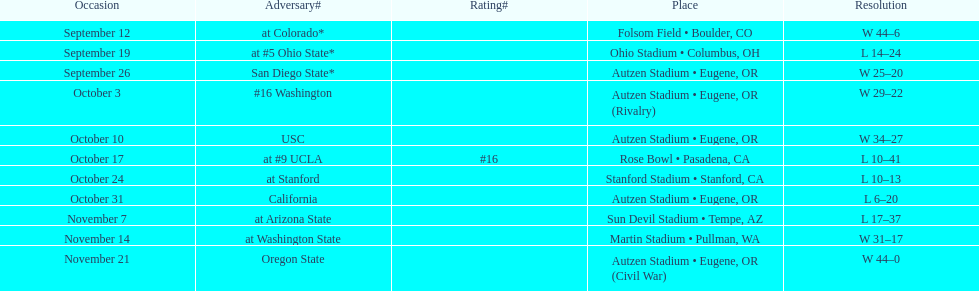How many games did the team win while not at home? 2. 